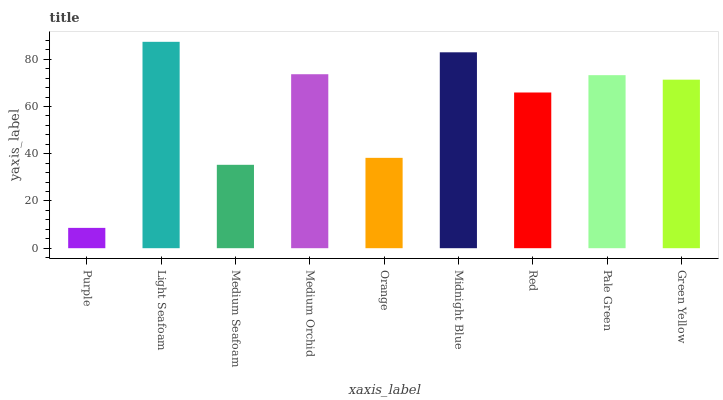Is Purple the minimum?
Answer yes or no. Yes. Is Light Seafoam the maximum?
Answer yes or no. Yes. Is Medium Seafoam the minimum?
Answer yes or no. No. Is Medium Seafoam the maximum?
Answer yes or no. No. Is Light Seafoam greater than Medium Seafoam?
Answer yes or no. Yes. Is Medium Seafoam less than Light Seafoam?
Answer yes or no. Yes. Is Medium Seafoam greater than Light Seafoam?
Answer yes or no. No. Is Light Seafoam less than Medium Seafoam?
Answer yes or no. No. Is Green Yellow the high median?
Answer yes or no. Yes. Is Green Yellow the low median?
Answer yes or no. Yes. Is Red the high median?
Answer yes or no. No. Is Medium Orchid the low median?
Answer yes or no. No. 